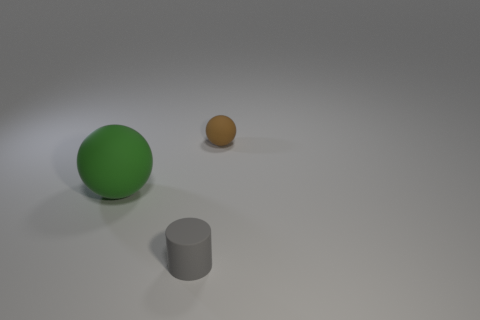What is the color of the sphere left of the tiny thing right of the small gray matte cylinder left of the small brown ball?
Make the answer very short. Green. There is a gray object; is its shape the same as the thing that is left of the small gray rubber object?
Your answer should be compact. No. There is a object that is both on the right side of the large green object and to the left of the tiny rubber sphere; what is its color?
Your response must be concise. Gray. Are there any other rubber things of the same shape as the brown matte thing?
Offer a terse response. Yes. Is the color of the tiny matte cylinder the same as the big rubber ball?
Make the answer very short. No. Are there any gray cylinders in front of the sphere on the right side of the small matte cylinder?
Your response must be concise. Yes. What number of objects are cylinders that are in front of the green rubber object or small things that are behind the green thing?
Offer a terse response. 2. How many objects are brown metal balls or small objects that are in front of the tiny rubber ball?
Make the answer very short. 1. There is a green sphere that is left of the tiny rubber object that is left of the sphere right of the green sphere; what size is it?
Give a very brief answer. Large. There is a brown object that is the same size as the gray thing; what is its material?
Your response must be concise. Rubber. 